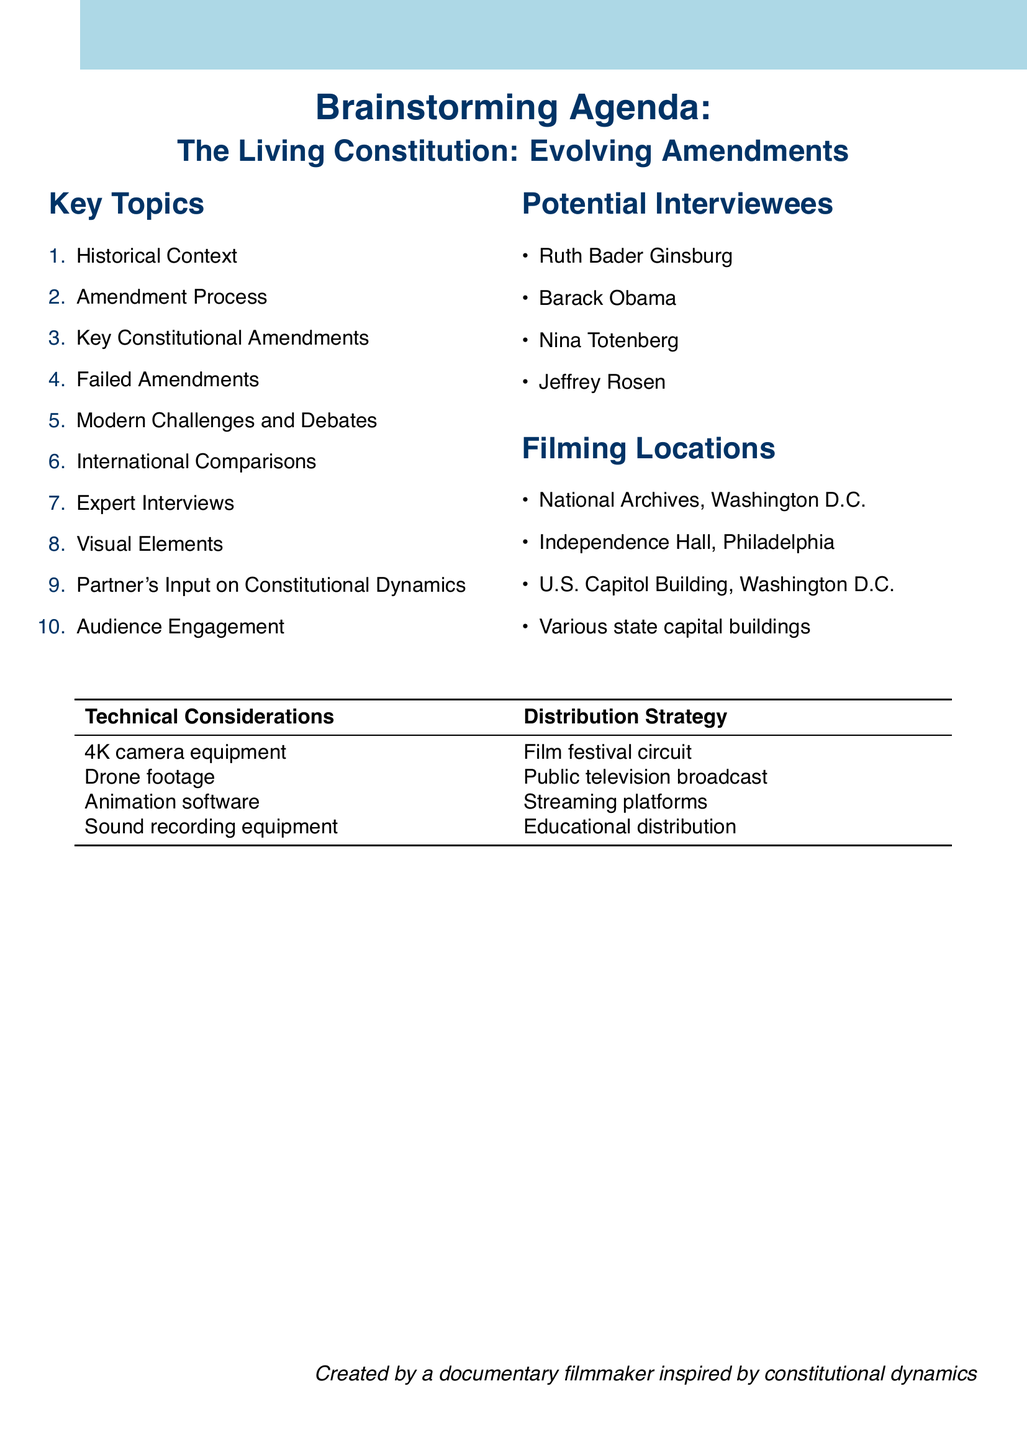What is the title of the documentary? The title of the documentary is stated at the beginning of the document, specifying its focus on constitutional amendments.
Answer: The Living Constitution: Evolving Amendments How many key topics are listed in the brainstorming agenda? The document lists a total of ten key topics under "Key Topics."
Answer: 10 Who is one potential interviewee mentioned in the document? The document provides a list of potential interviewees for expert insights; one of them is Ruth Bader Ginsburg.
Answer: Ruth Bader Ginsburg What is one filming location specified in the document? The document mentions various filming locations, including the National Archives in Washington D.C.
Answer: National Archives, Washington D.C What technical consideration includes equipment for historical document shots? The document lists specific technical considerations, including 4K camera equipment.
Answer: 4K camera equipment Which strategy involves distributing the documentary through film festivals? The distribution strategy mentioned includes several ways to reach audiences, one of which is the film festival circuit.
Answer: Film festival circuit What constitutional amendment is associated with women's suffrage? The document includes a section on key constitutional amendments, identifying the 19th Amendment as related to this topic.
Answer: 19th Amendment How does the document propose to engage the audience? One suggested method from the document for audience engagement is a social media campaign.
Answer: Social media campaign: #MyConstitutionalAmendment 